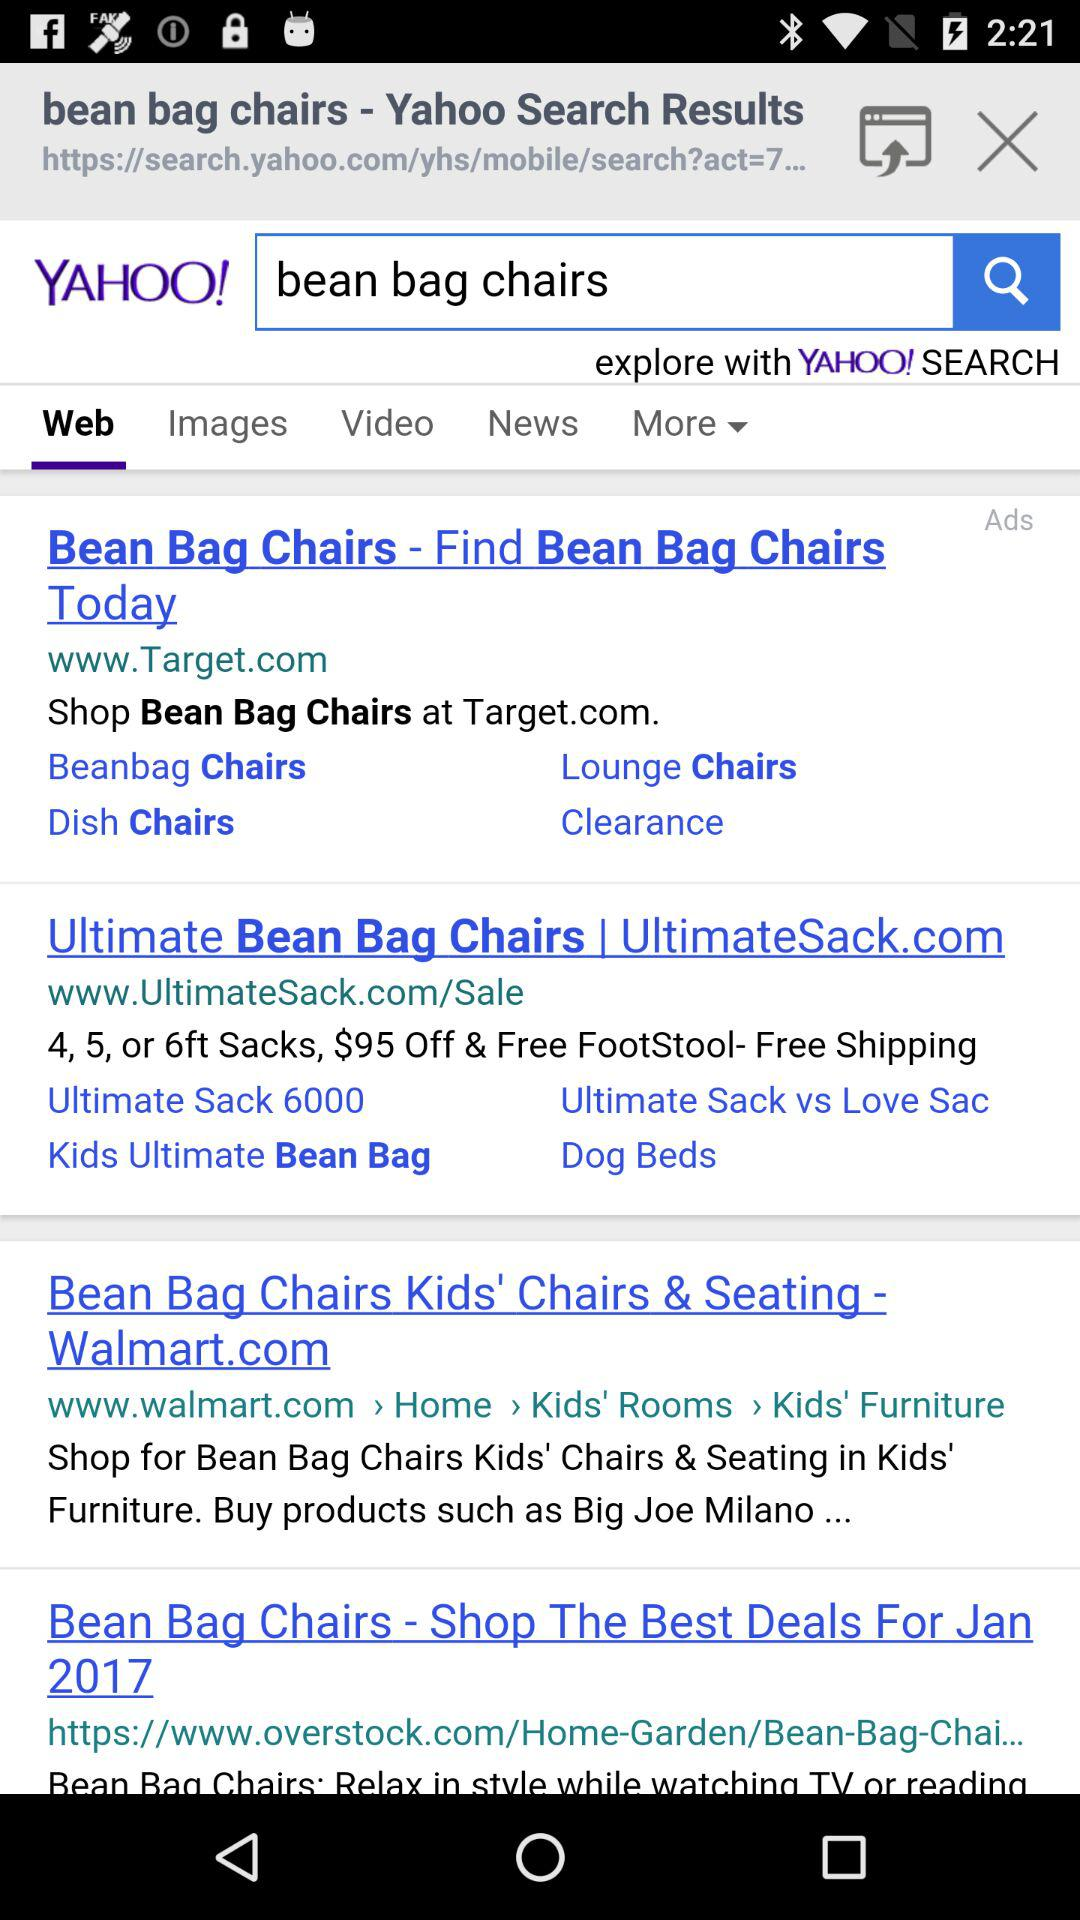What is the entered term in the search bar? The entered term in the search bar is "bean bag chairs". 